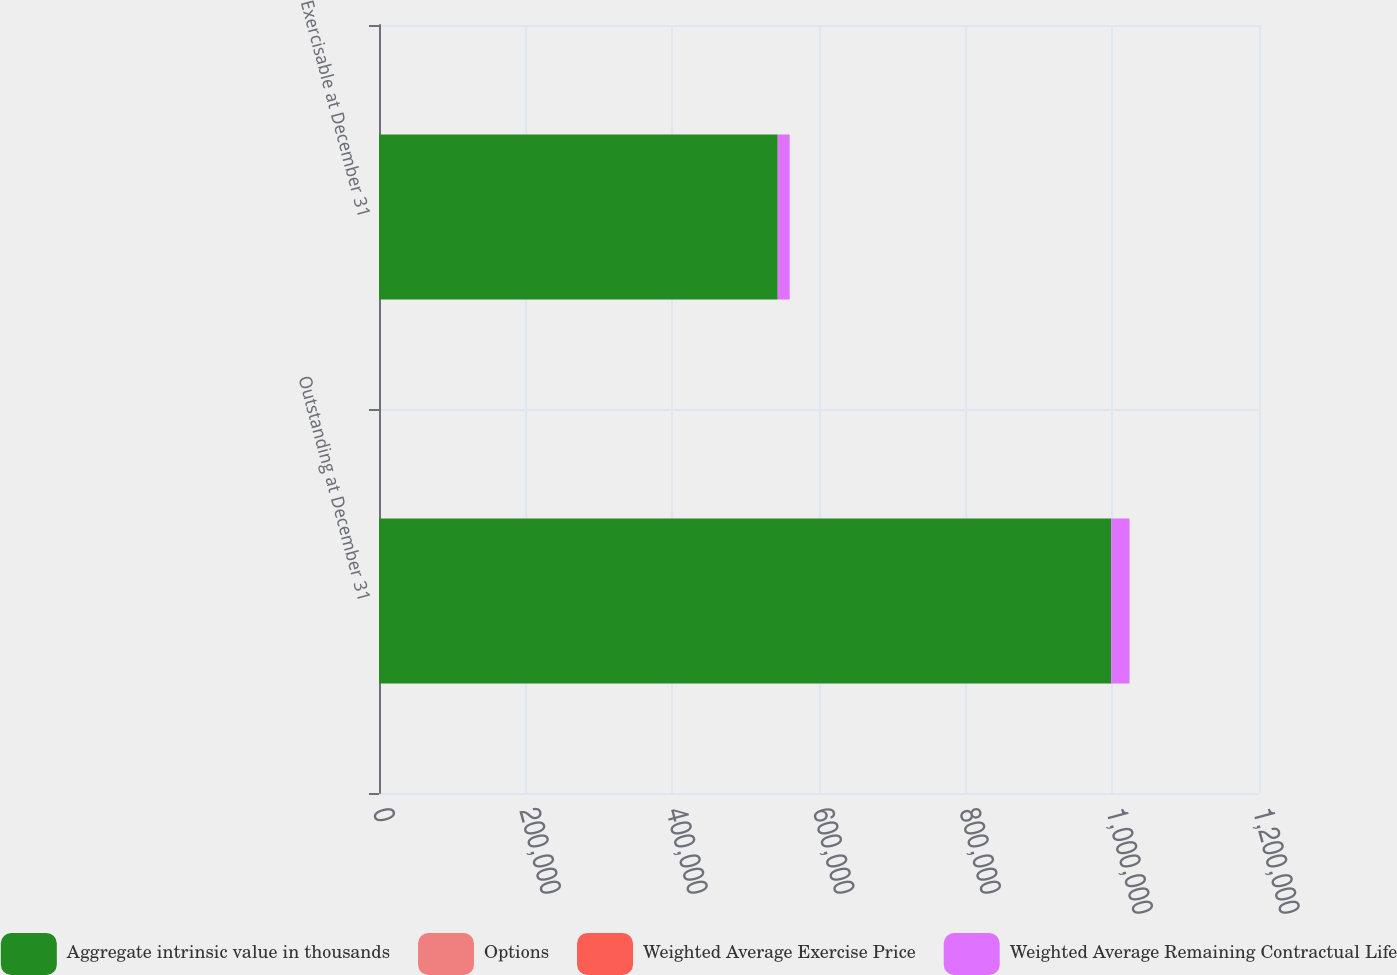Convert chart to OTSL. <chart><loc_0><loc_0><loc_500><loc_500><stacked_bar_chart><ecel><fcel>Outstanding at December 31<fcel>Exercisable at December 31<nl><fcel>Aggregate intrinsic value in thousands<fcel>998389<fcel>543705<nl><fcel>Options<fcel>27.83<fcel>22.88<nl><fcel>Weighted Average Exercise Price<fcel>6.2<fcel>5<nl><fcel>Weighted Average Remaining Contractual Life<fcel>25018<fcel>16317<nl></chart> 